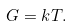<formula> <loc_0><loc_0><loc_500><loc_500>G = k T .</formula> 